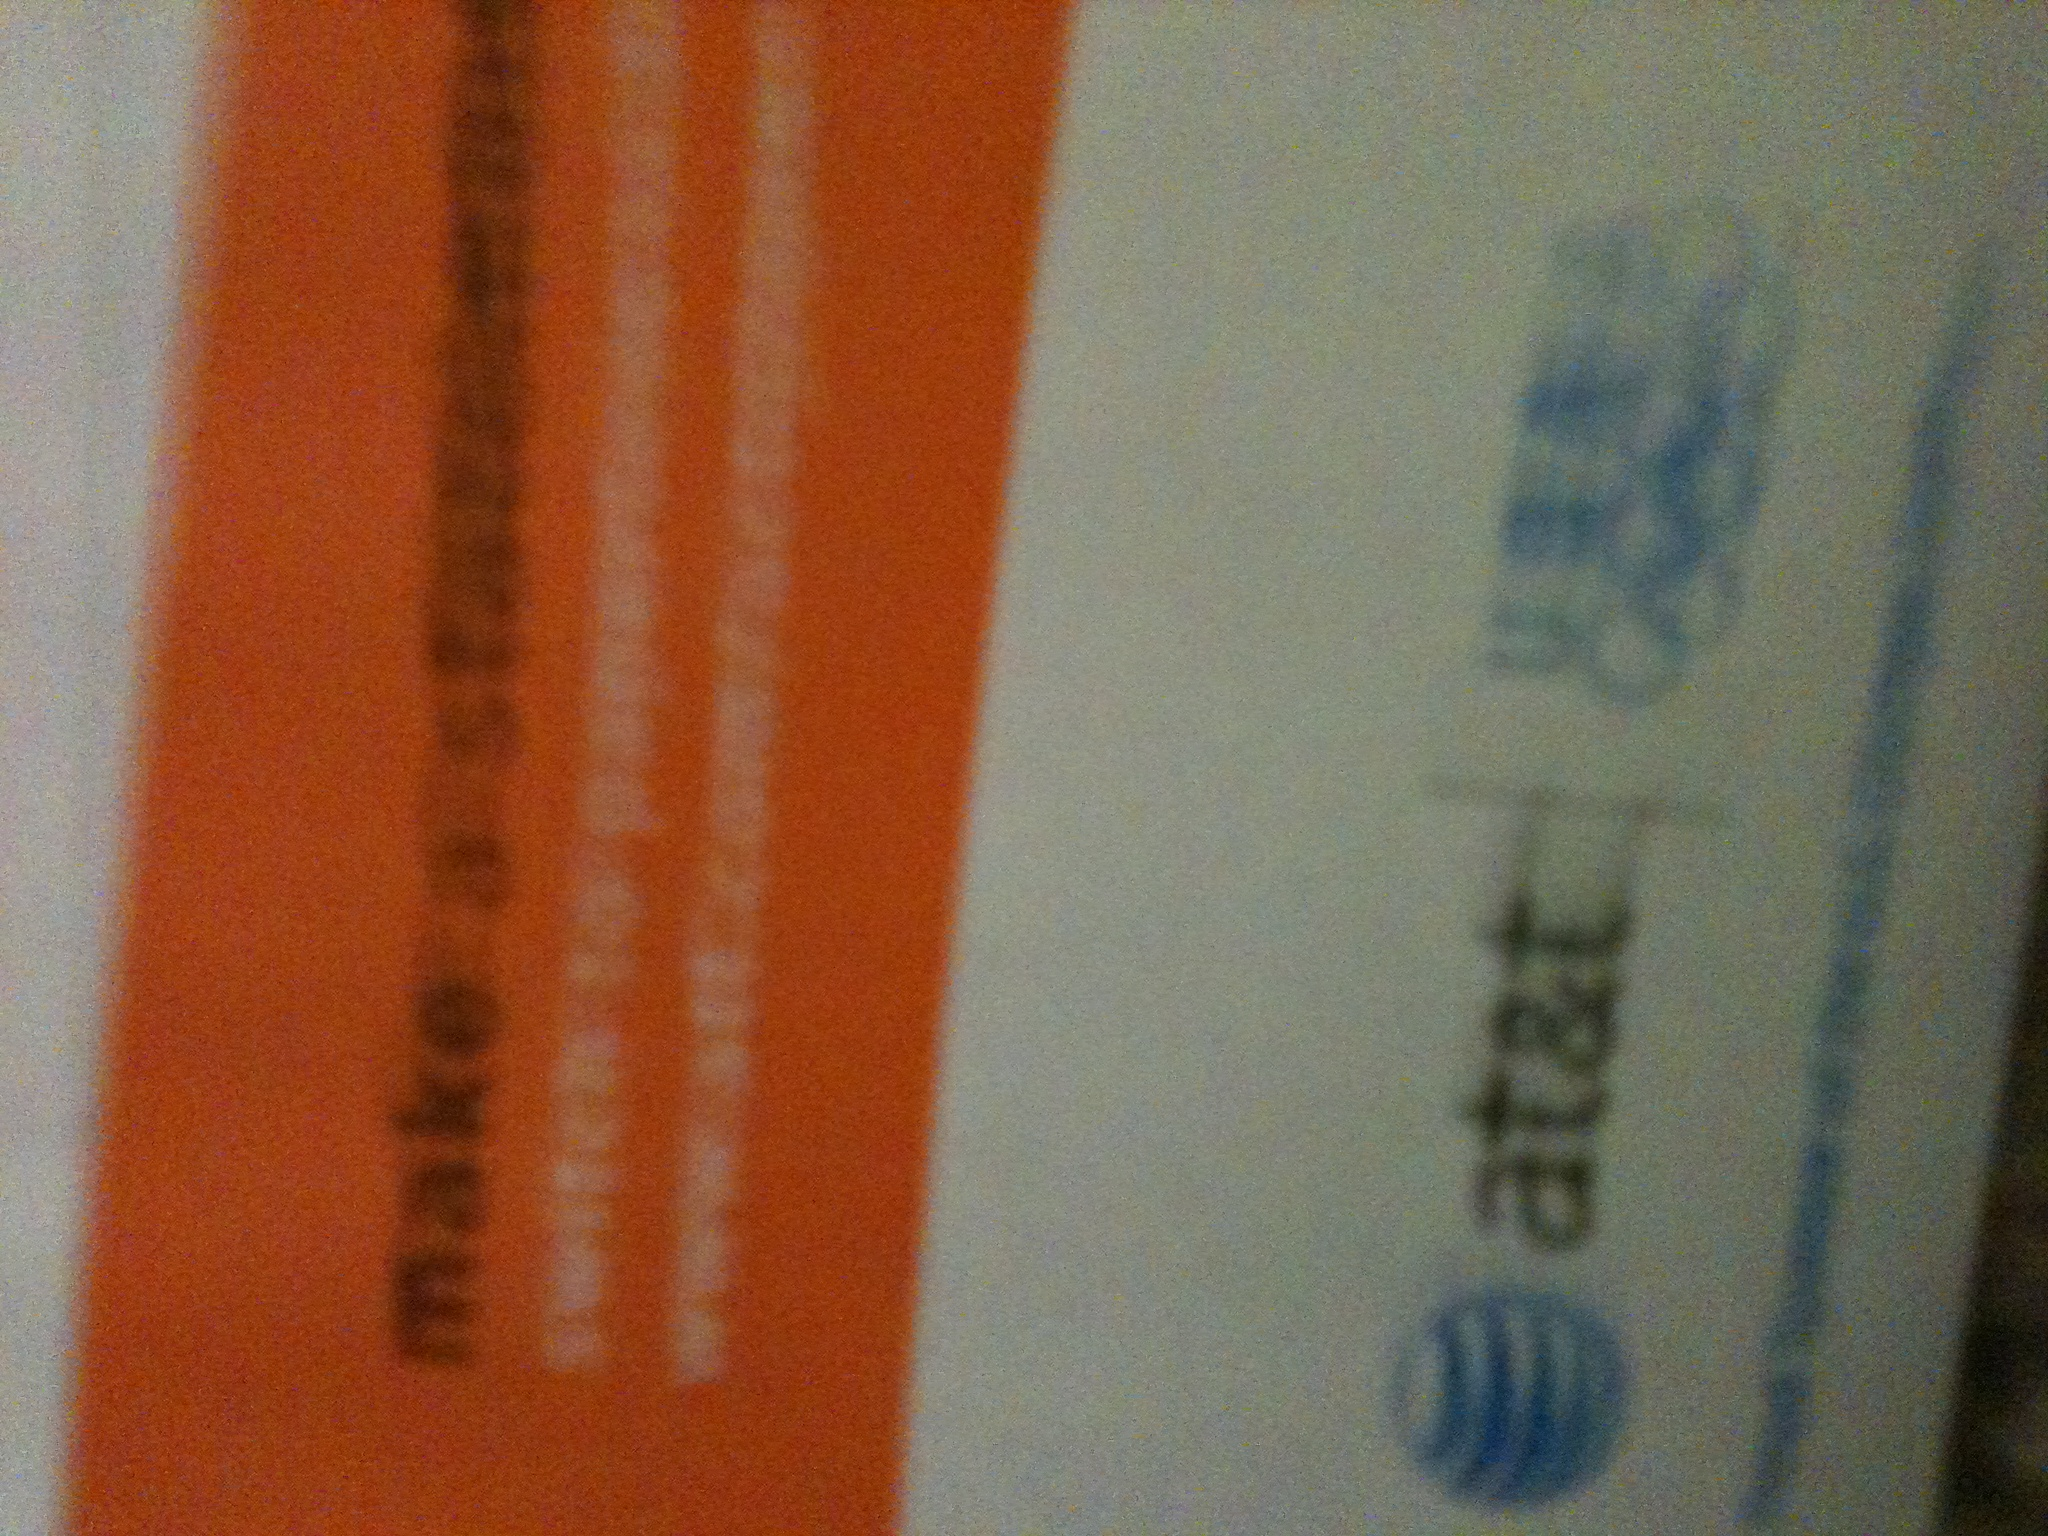What offers might be detailed in this AT&T advertisement? Due to the image's blurriness, specific offers are not clearly visible. It seems to encourage making savings, hinting at possible deals or discounts on services. 